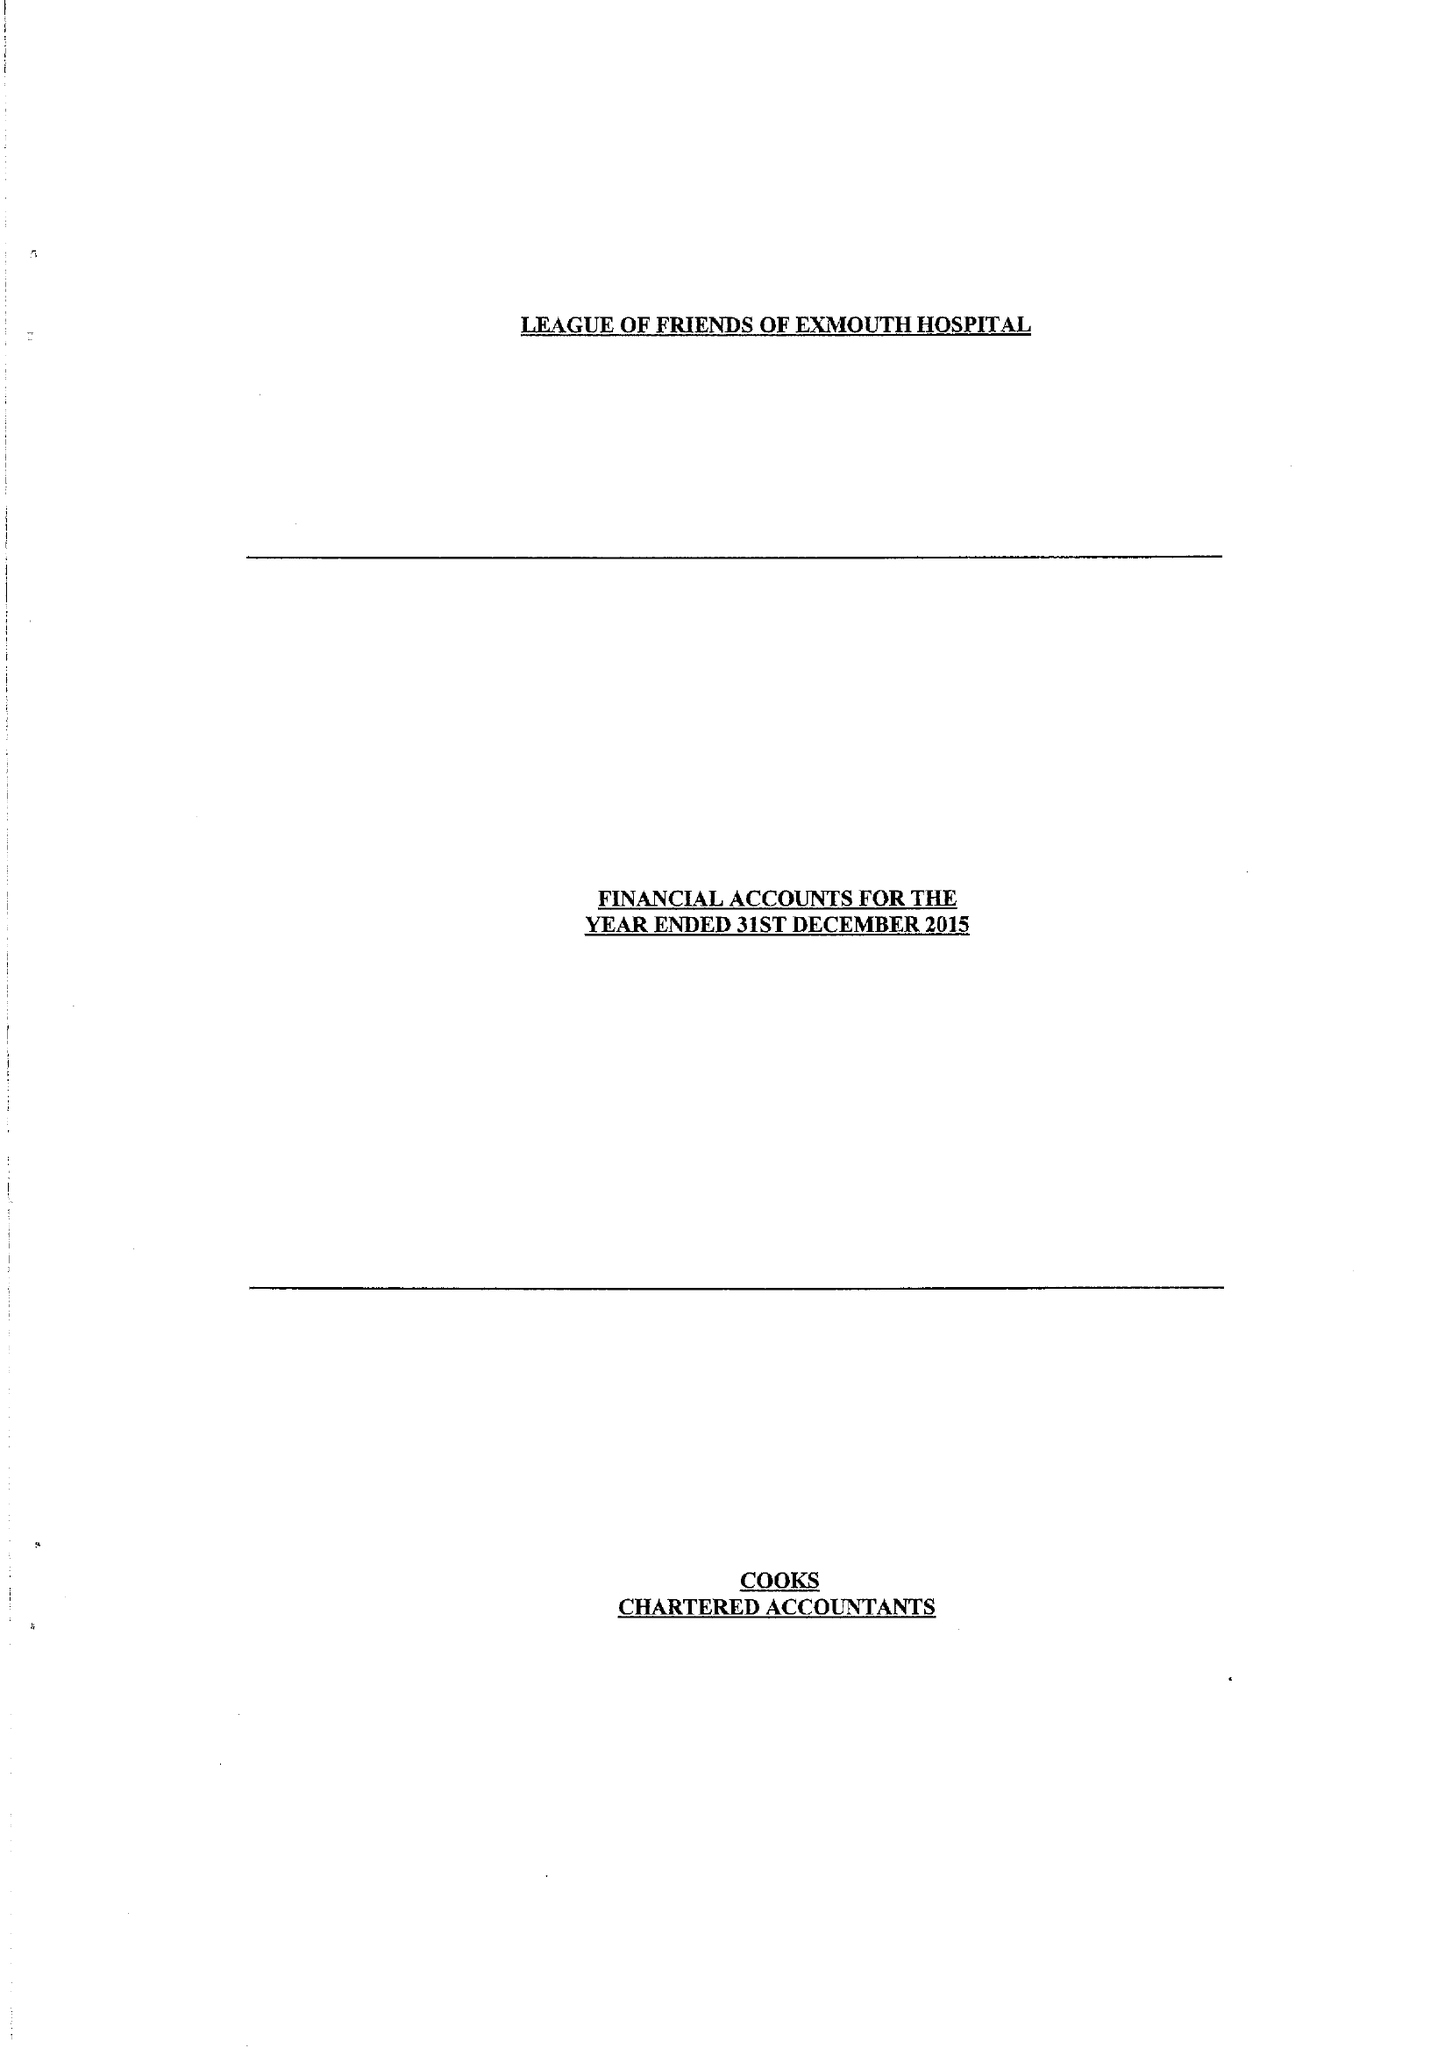What is the value for the address__postcode?
Answer the question using a single word or phrase. EX8 2JN 